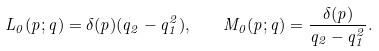Convert formula to latex. <formula><loc_0><loc_0><loc_500><loc_500>L _ { 0 } ( p ; q ) = \delta ( p ) ( q _ { 2 } - q _ { 1 } ^ { 2 } ) , \quad M _ { 0 } ( p ; q ) = \frac { \delta ( p ) } { q _ { 2 } - q _ { 1 } ^ { 2 } } .</formula> 